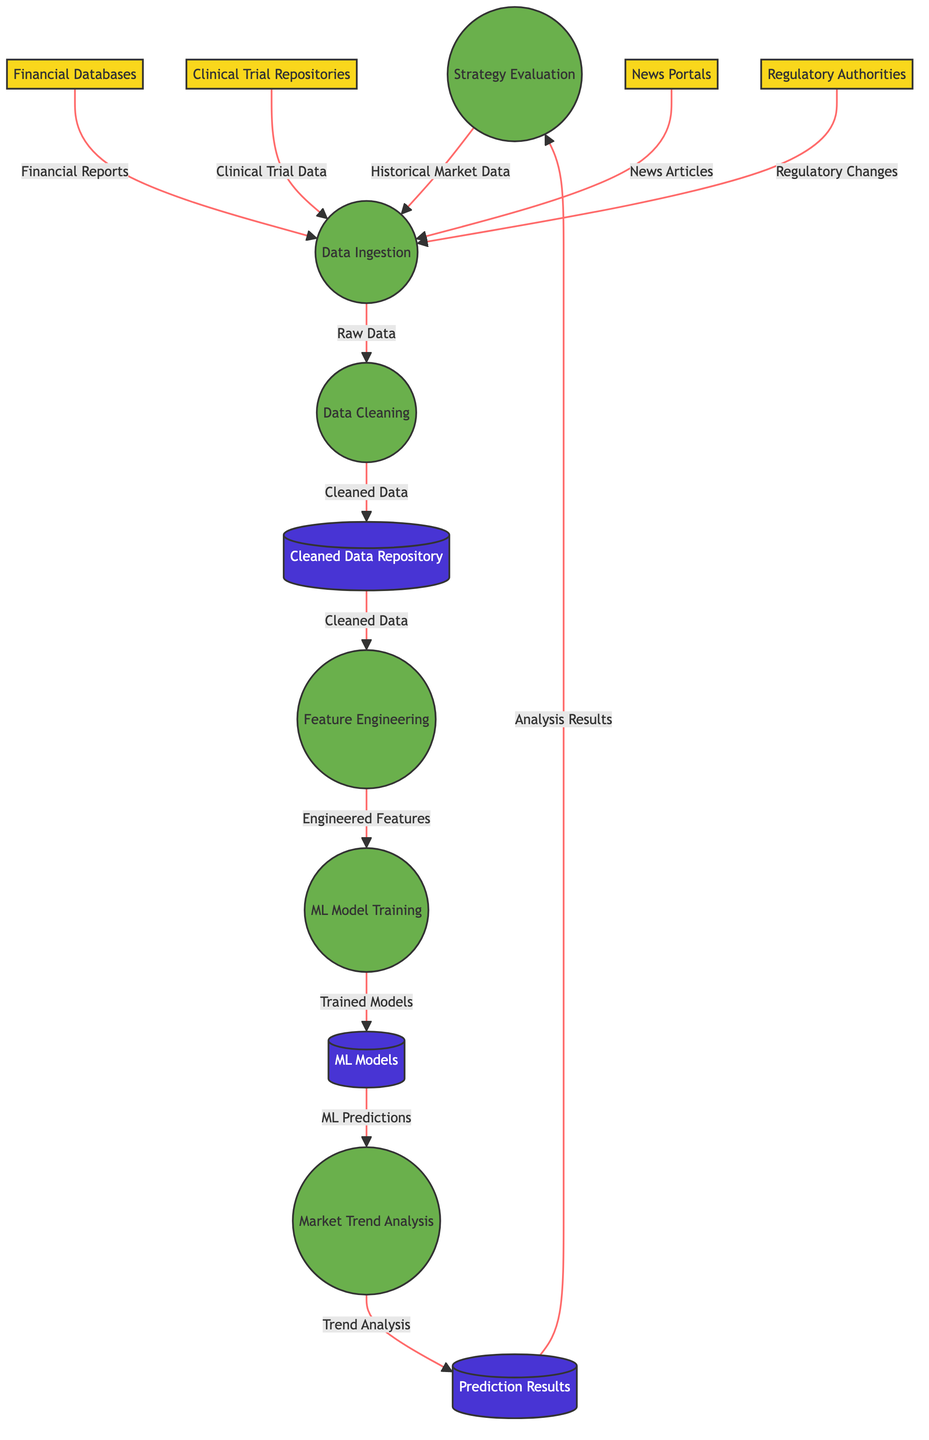What is the first process in the diagram? The first process is Data Ingestion, which receives data from various external entities.
Answer: Data Ingestion How many external entities are represented in the diagram? There are five external entities providing data to the system: Stock Exchange, Financial Databases, Clinical Trial Repositories, News Portals, and Regulatory Authorities.
Answer: Five Which data store holds the cleaned data? The cleaned data is stored in the Cleaned Data Repository after the Data Cleaning process is completed.
Answer: Cleaned Data Repository What type of data flows into the Machine Learning Model Training process? The Machine Learning Model Training process uses Engineered Features that are generated from the cleaned data.
Answer: Engineered Features Which process produces the Trend Analysis Results? The Market Trend Analysis process outputs the Trend Analysis Results into the Prediction Results data store.
Answer: Market Trend Analysis How does Regulatory Changes data contribute to the process? Regulatory Changes data from Regulatory Authorities is ingested during the Data Ingestion process, helping to evaluate the market context.
Answer: Data Ingestion What is the last process in the data flow? The last process is Strategy Evaluation, which assesses the investment strategies based on the trend analysis results.
Answer: Strategy Evaluation Which entity provides the Clinical Trial Data? Clinical Trial Repositories are the external entity that supplies Clinical Trial Data to the Data Ingestion process.
Answer: Clinical Trial Repositories In which process are machine learning models trained? Machine Learning Model Training is the process where machine learning models are trained using the engineered features.
Answer: Machine Learning Model Training 